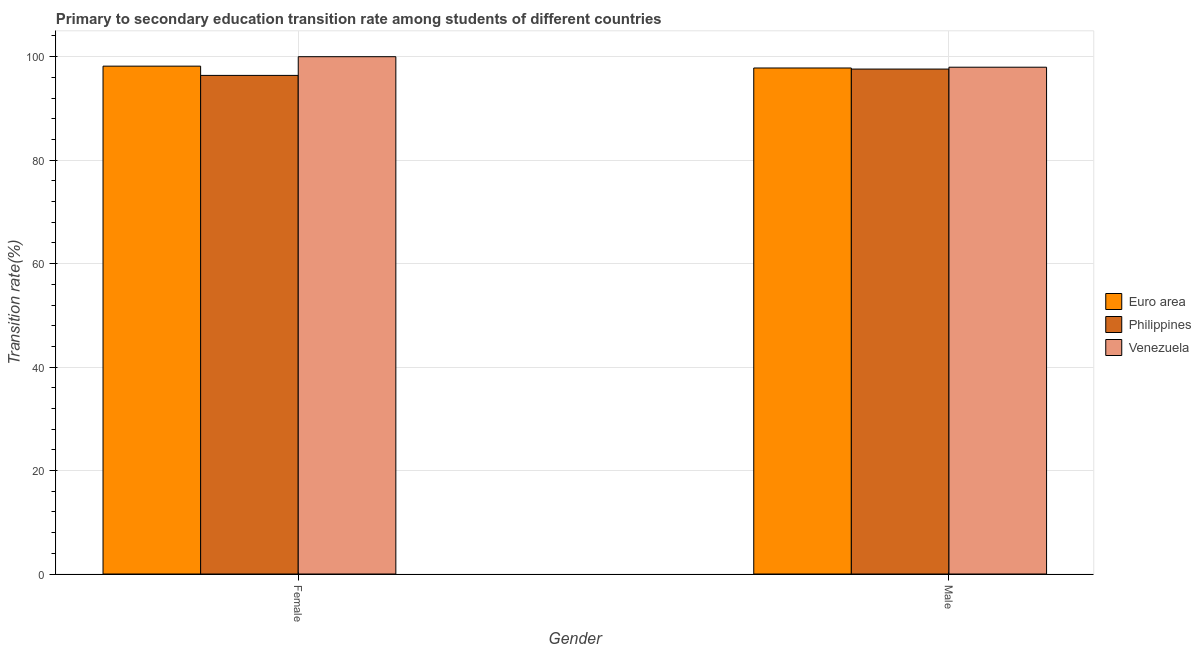How many different coloured bars are there?
Offer a very short reply. 3. How many groups of bars are there?
Make the answer very short. 2. How many bars are there on the 2nd tick from the left?
Provide a succinct answer. 3. How many bars are there on the 1st tick from the right?
Offer a terse response. 3. What is the label of the 1st group of bars from the left?
Ensure brevity in your answer.  Female. What is the transition rate among female students in Euro area?
Provide a succinct answer. 98.17. Across all countries, what is the maximum transition rate among female students?
Give a very brief answer. 100. Across all countries, what is the minimum transition rate among male students?
Ensure brevity in your answer.  97.61. In which country was the transition rate among male students maximum?
Give a very brief answer. Venezuela. What is the total transition rate among female students in the graph?
Your answer should be compact. 294.56. What is the difference between the transition rate among female students in Euro area and that in Venezuela?
Make the answer very short. -1.83. What is the difference between the transition rate among male students in Euro area and the transition rate among female students in Philippines?
Ensure brevity in your answer.  1.43. What is the average transition rate among male students per country?
Provide a short and direct response. 97.8. What is the difference between the transition rate among female students and transition rate among male students in Philippines?
Make the answer very short. -1.22. In how many countries, is the transition rate among female students greater than 36 %?
Offer a very short reply. 3. What is the ratio of the transition rate among male students in Philippines to that in Venezuela?
Your answer should be compact. 1. In how many countries, is the transition rate among female students greater than the average transition rate among female students taken over all countries?
Ensure brevity in your answer.  1. What does the 1st bar from the left in Male represents?
Offer a very short reply. Euro area. What does the 2nd bar from the right in Female represents?
Offer a terse response. Philippines. Are all the bars in the graph horizontal?
Your answer should be compact. No. How many countries are there in the graph?
Provide a succinct answer. 3. What is the difference between two consecutive major ticks on the Y-axis?
Offer a terse response. 20. Are the values on the major ticks of Y-axis written in scientific E-notation?
Provide a succinct answer. No. Does the graph contain any zero values?
Provide a short and direct response. No. Does the graph contain grids?
Provide a short and direct response. Yes. How many legend labels are there?
Provide a succinct answer. 3. What is the title of the graph?
Provide a short and direct response. Primary to secondary education transition rate among students of different countries. Does "Djibouti" appear as one of the legend labels in the graph?
Your answer should be very brief. No. What is the label or title of the X-axis?
Your answer should be compact. Gender. What is the label or title of the Y-axis?
Offer a very short reply. Transition rate(%). What is the Transition rate(%) in Euro area in Female?
Provide a short and direct response. 98.17. What is the Transition rate(%) of Philippines in Female?
Offer a very short reply. 96.38. What is the Transition rate(%) in Venezuela in Female?
Offer a very short reply. 100. What is the Transition rate(%) in Euro area in Male?
Provide a succinct answer. 97.82. What is the Transition rate(%) in Philippines in Male?
Keep it short and to the point. 97.61. What is the Transition rate(%) of Venezuela in Male?
Offer a terse response. 97.97. Across all Gender, what is the maximum Transition rate(%) in Euro area?
Provide a short and direct response. 98.17. Across all Gender, what is the maximum Transition rate(%) in Philippines?
Keep it short and to the point. 97.61. Across all Gender, what is the maximum Transition rate(%) in Venezuela?
Give a very brief answer. 100. Across all Gender, what is the minimum Transition rate(%) of Euro area?
Keep it short and to the point. 97.82. Across all Gender, what is the minimum Transition rate(%) of Philippines?
Give a very brief answer. 96.38. Across all Gender, what is the minimum Transition rate(%) of Venezuela?
Provide a succinct answer. 97.97. What is the total Transition rate(%) in Euro area in the graph?
Your answer should be very brief. 195.99. What is the total Transition rate(%) of Philippines in the graph?
Make the answer very short. 193.99. What is the total Transition rate(%) in Venezuela in the graph?
Keep it short and to the point. 197.97. What is the difference between the Transition rate(%) in Euro area in Female and that in Male?
Offer a very short reply. 0.36. What is the difference between the Transition rate(%) of Philippines in Female and that in Male?
Keep it short and to the point. -1.22. What is the difference between the Transition rate(%) in Venezuela in Female and that in Male?
Offer a terse response. 2.03. What is the difference between the Transition rate(%) of Euro area in Female and the Transition rate(%) of Philippines in Male?
Offer a very short reply. 0.56. What is the difference between the Transition rate(%) of Euro area in Female and the Transition rate(%) of Venezuela in Male?
Provide a succinct answer. 0.21. What is the difference between the Transition rate(%) of Philippines in Female and the Transition rate(%) of Venezuela in Male?
Provide a succinct answer. -1.58. What is the average Transition rate(%) of Euro area per Gender?
Offer a very short reply. 97.99. What is the average Transition rate(%) in Philippines per Gender?
Your answer should be compact. 97. What is the average Transition rate(%) of Venezuela per Gender?
Ensure brevity in your answer.  98.98. What is the difference between the Transition rate(%) of Euro area and Transition rate(%) of Philippines in Female?
Ensure brevity in your answer.  1.79. What is the difference between the Transition rate(%) in Euro area and Transition rate(%) in Venezuela in Female?
Offer a very short reply. -1.83. What is the difference between the Transition rate(%) of Philippines and Transition rate(%) of Venezuela in Female?
Offer a very short reply. -3.62. What is the difference between the Transition rate(%) of Euro area and Transition rate(%) of Philippines in Male?
Offer a very short reply. 0.21. What is the difference between the Transition rate(%) of Euro area and Transition rate(%) of Venezuela in Male?
Ensure brevity in your answer.  -0.15. What is the difference between the Transition rate(%) in Philippines and Transition rate(%) in Venezuela in Male?
Keep it short and to the point. -0.36. What is the ratio of the Transition rate(%) of Euro area in Female to that in Male?
Offer a terse response. 1. What is the ratio of the Transition rate(%) in Philippines in Female to that in Male?
Offer a terse response. 0.99. What is the ratio of the Transition rate(%) in Venezuela in Female to that in Male?
Your answer should be very brief. 1.02. What is the difference between the highest and the second highest Transition rate(%) in Euro area?
Provide a succinct answer. 0.36. What is the difference between the highest and the second highest Transition rate(%) in Philippines?
Keep it short and to the point. 1.22. What is the difference between the highest and the second highest Transition rate(%) of Venezuela?
Offer a very short reply. 2.03. What is the difference between the highest and the lowest Transition rate(%) of Euro area?
Offer a very short reply. 0.36. What is the difference between the highest and the lowest Transition rate(%) of Philippines?
Give a very brief answer. 1.22. What is the difference between the highest and the lowest Transition rate(%) in Venezuela?
Your response must be concise. 2.03. 